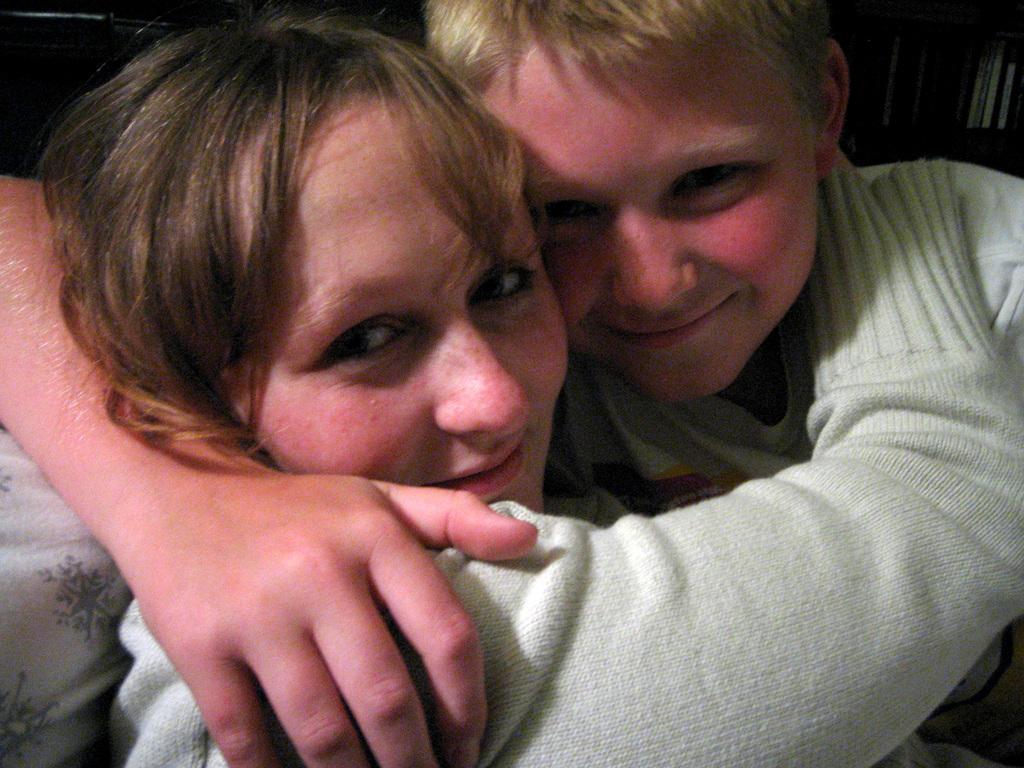How would you summarize this image in a sentence or two? In this image there is a woman towards the bottom of the image, there is a boy towards the right of the image, they are hugging each other, there is an object towards the right of the image, there is an object towards the top of the image, the background of the image is blurred. 